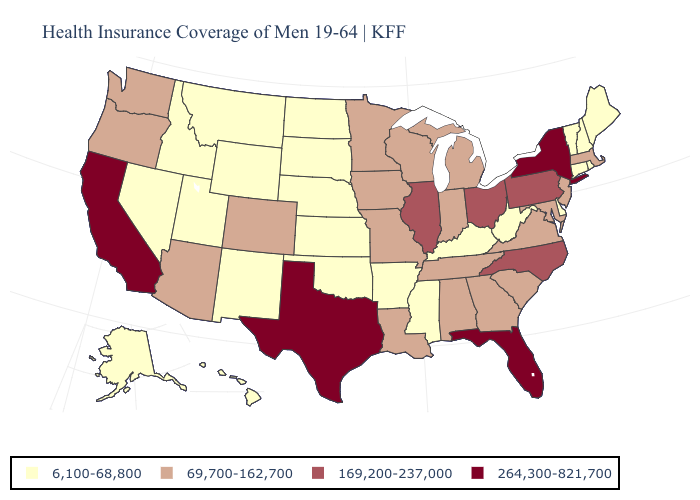Does Maine have the same value as Kansas?
Give a very brief answer. Yes. Name the states that have a value in the range 264,300-821,700?
Give a very brief answer. California, Florida, New York, Texas. Among the states that border Massachusetts , does Rhode Island have the lowest value?
Be succinct. Yes. What is the lowest value in states that border Connecticut?
Answer briefly. 6,100-68,800. Which states have the lowest value in the USA?
Concise answer only. Alaska, Arkansas, Connecticut, Delaware, Hawaii, Idaho, Kansas, Kentucky, Maine, Mississippi, Montana, Nebraska, Nevada, New Hampshire, New Mexico, North Dakota, Oklahoma, Rhode Island, South Dakota, Utah, Vermont, West Virginia, Wyoming. Among the states that border Virginia , does West Virginia have the lowest value?
Concise answer only. Yes. Name the states that have a value in the range 264,300-821,700?
Keep it brief. California, Florida, New York, Texas. Does Louisiana have the same value as Idaho?
Short answer required. No. Name the states that have a value in the range 169,200-237,000?
Concise answer only. Illinois, North Carolina, Ohio, Pennsylvania. Does Texas have a higher value than New Mexico?
Give a very brief answer. Yes. Name the states that have a value in the range 6,100-68,800?
Answer briefly. Alaska, Arkansas, Connecticut, Delaware, Hawaii, Idaho, Kansas, Kentucky, Maine, Mississippi, Montana, Nebraska, Nevada, New Hampshire, New Mexico, North Dakota, Oklahoma, Rhode Island, South Dakota, Utah, Vermont, West Virginia, Wyoming. What is the value of New Hampshire?
Be succinct. 6,100-68,800. Does Georgia have a higher value than Idaho?
Quick response, please. Yes. Does the map have missing data?
Write a very short answer. No. What is the highest value in the USA?
Answer briefly. 264,300-821,700. 